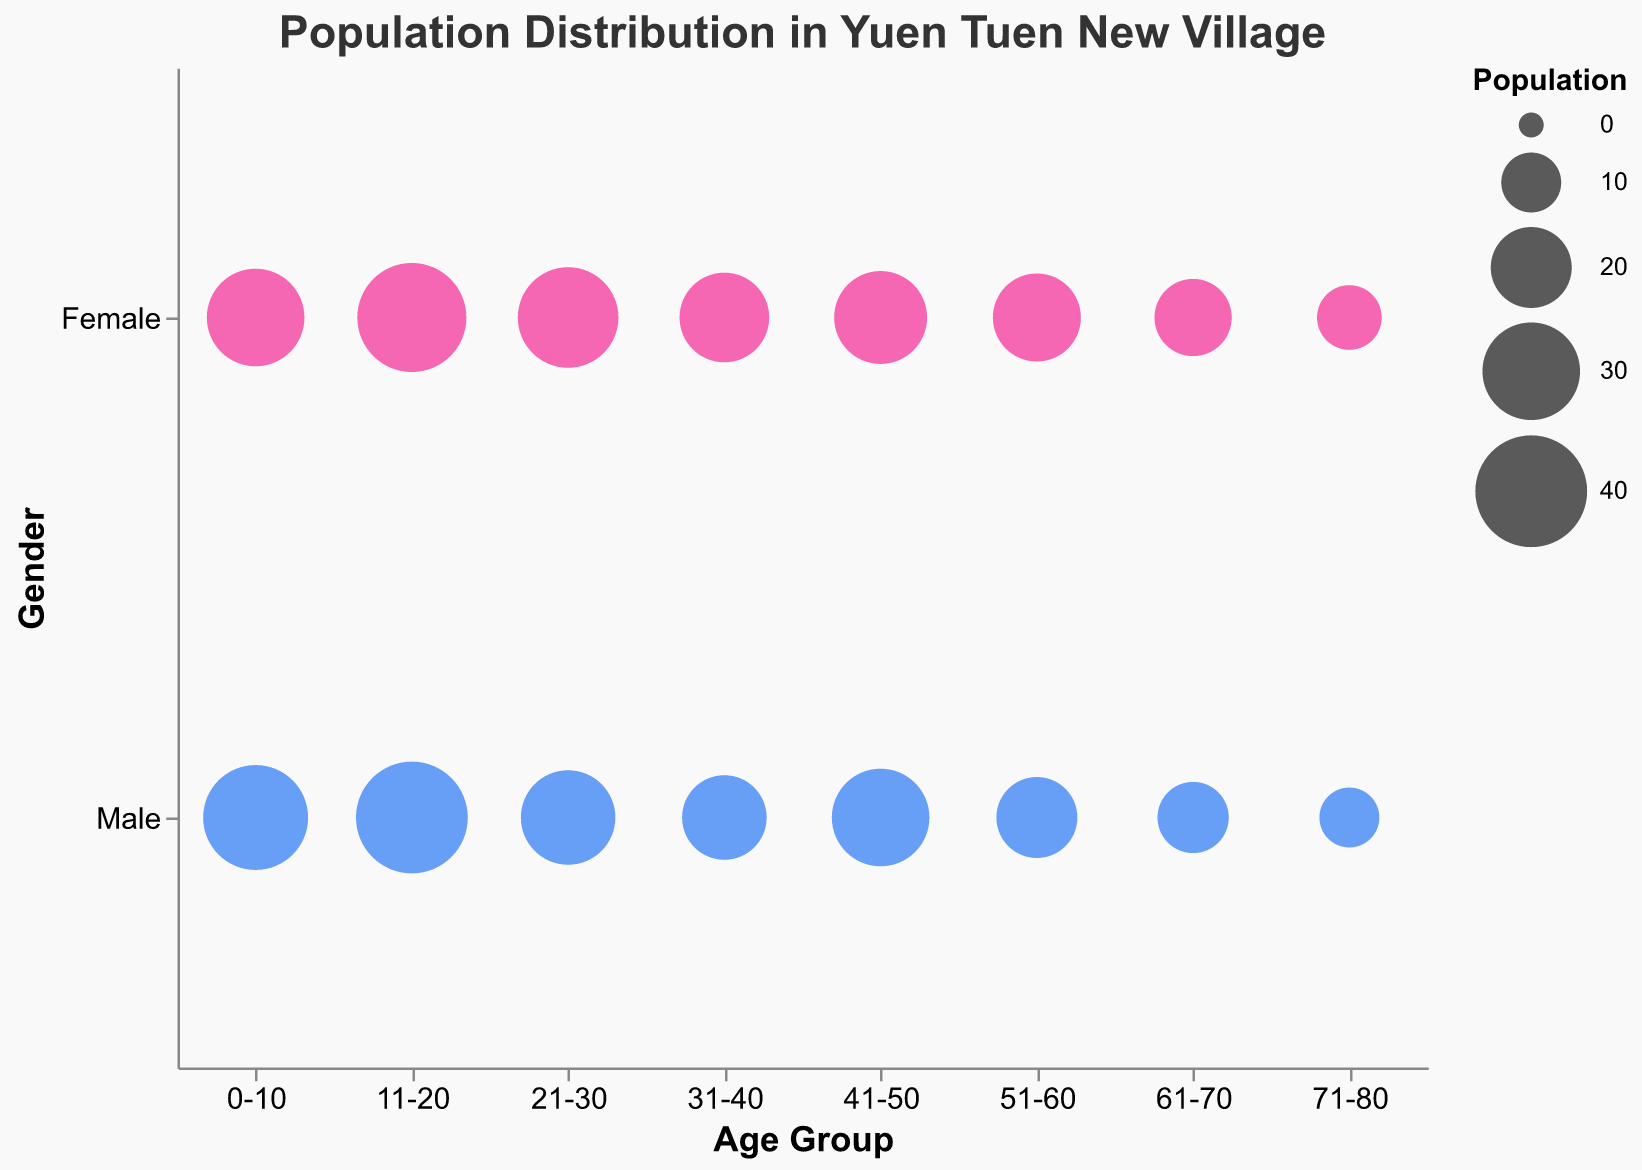What is the title of the figure? The title is usually positioned at the top of the figure and gives an overview of the data being displayed. The title here reads, "Population Distribution in Yuen Tuen New Village."
Answer: Population Distribution in Yuen Tuen New Village What are the two gender categories shown in the figure? The figure uses colors to represent different gender categories. These categories can be seen in the legend and tooltips. The two gender categories are "Male" and "Female".
Answer: Male, Female Which age group has the highest population for males? From the figure, we can see the size of the bubbles, and the largest bubble for males indicates the highest population. The bubble for males in the "11-20" age group is the largest.
Answer: 11-20 Compare the population of females in the 0-10 and 71-80 age groups. By observing the bubbles for females in the 0-10 and 71-80 age groups, we see that the bubble for 0-10 is larger than the one for 71-80. The population for 0-10 is 30, and for 71-80, it is 12.
Answer: 0-10 has a higher population What is the total population of the 21-30 age group? The total population is found by summing the male and female populations in this age group. The male population is 28, and the female population is 32. So, 28 + 32 = 60.
Answer: 60 Which age group has the smallest population for females, and what is it? By observing the size of the bubbles for females, the smallest bubble corresponds to the age group 71-80, with a population of 12.
Answer: 71-80, 12 How does the population of males in the 31-40 age group compare to that of females in the same age group? By looking at the size of the bubbles, the male population is represented by a smaller bubble than that of the female in the 31-40 age group. Specifically, males have a population of 22, and females have 25.
Answer: Females have a higher population What is the gender distribution in the 51-60 age group? To determine this, look at the bubbles for the 51-60 age group and note their sizes. The male population is 20, and the female population is 24. So, males have 20 and females have 24.
Answer: Males: 20, Females: 24 